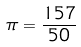Convert formula to latex. <formula><loc_0><loc_0><loc_500><loc_500>\pi = \frac { 1 5 7 } { 5 0 }</formula> 